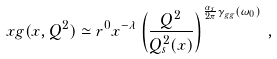Convert formula to latex. <formula><loc_0><loc_0><loc_500><loc_500>x g ( x , Q ^ { 2 } ) \simeq r ^ { 0 } x ^ { - \lambda } \left ( { \frac { Q ^ { 2 } } { Q _ { s } ^ { 2 } ( x ) } } \right ) ^ { { \frac { \alpha _ { s } } { 2 \pi } } \gamma _ { g g } ( \omega _ { 0 } ) } \, ,</formula> 